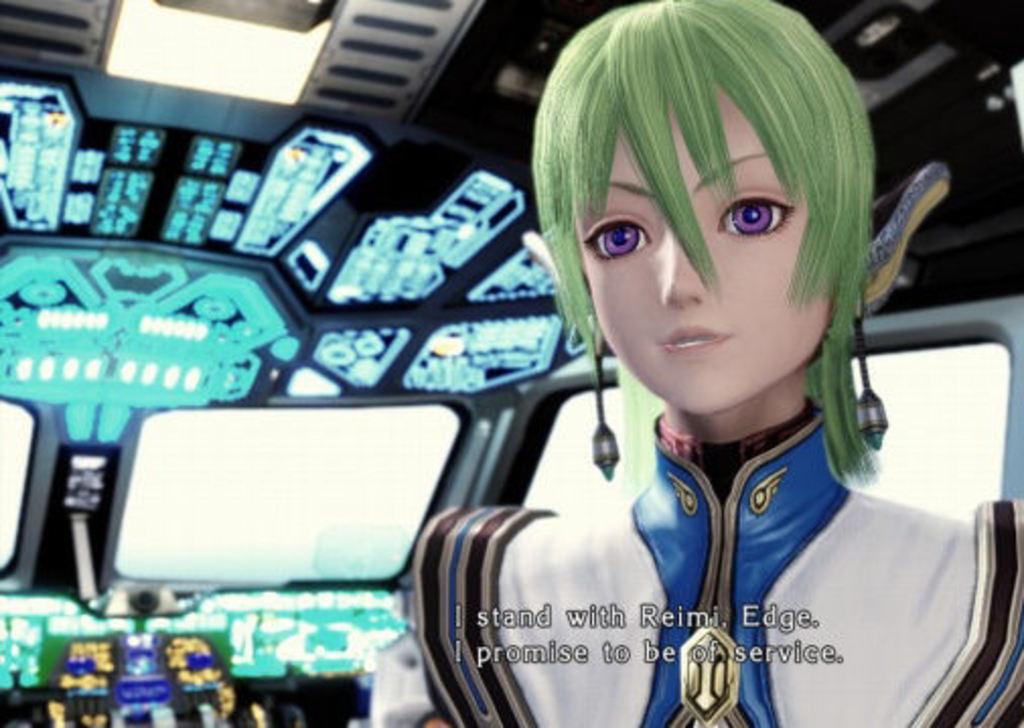Shes stands with who?
Your response must be concise. Reimi. 